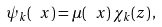Convert formula to latex. <formula><loc_0><loc_0><loc_500><loc_500>\psi _ { k } ( \ x ) = \mu ( \ x ) \, \chi _ { k } ( { z } ) \, ,</formula> 